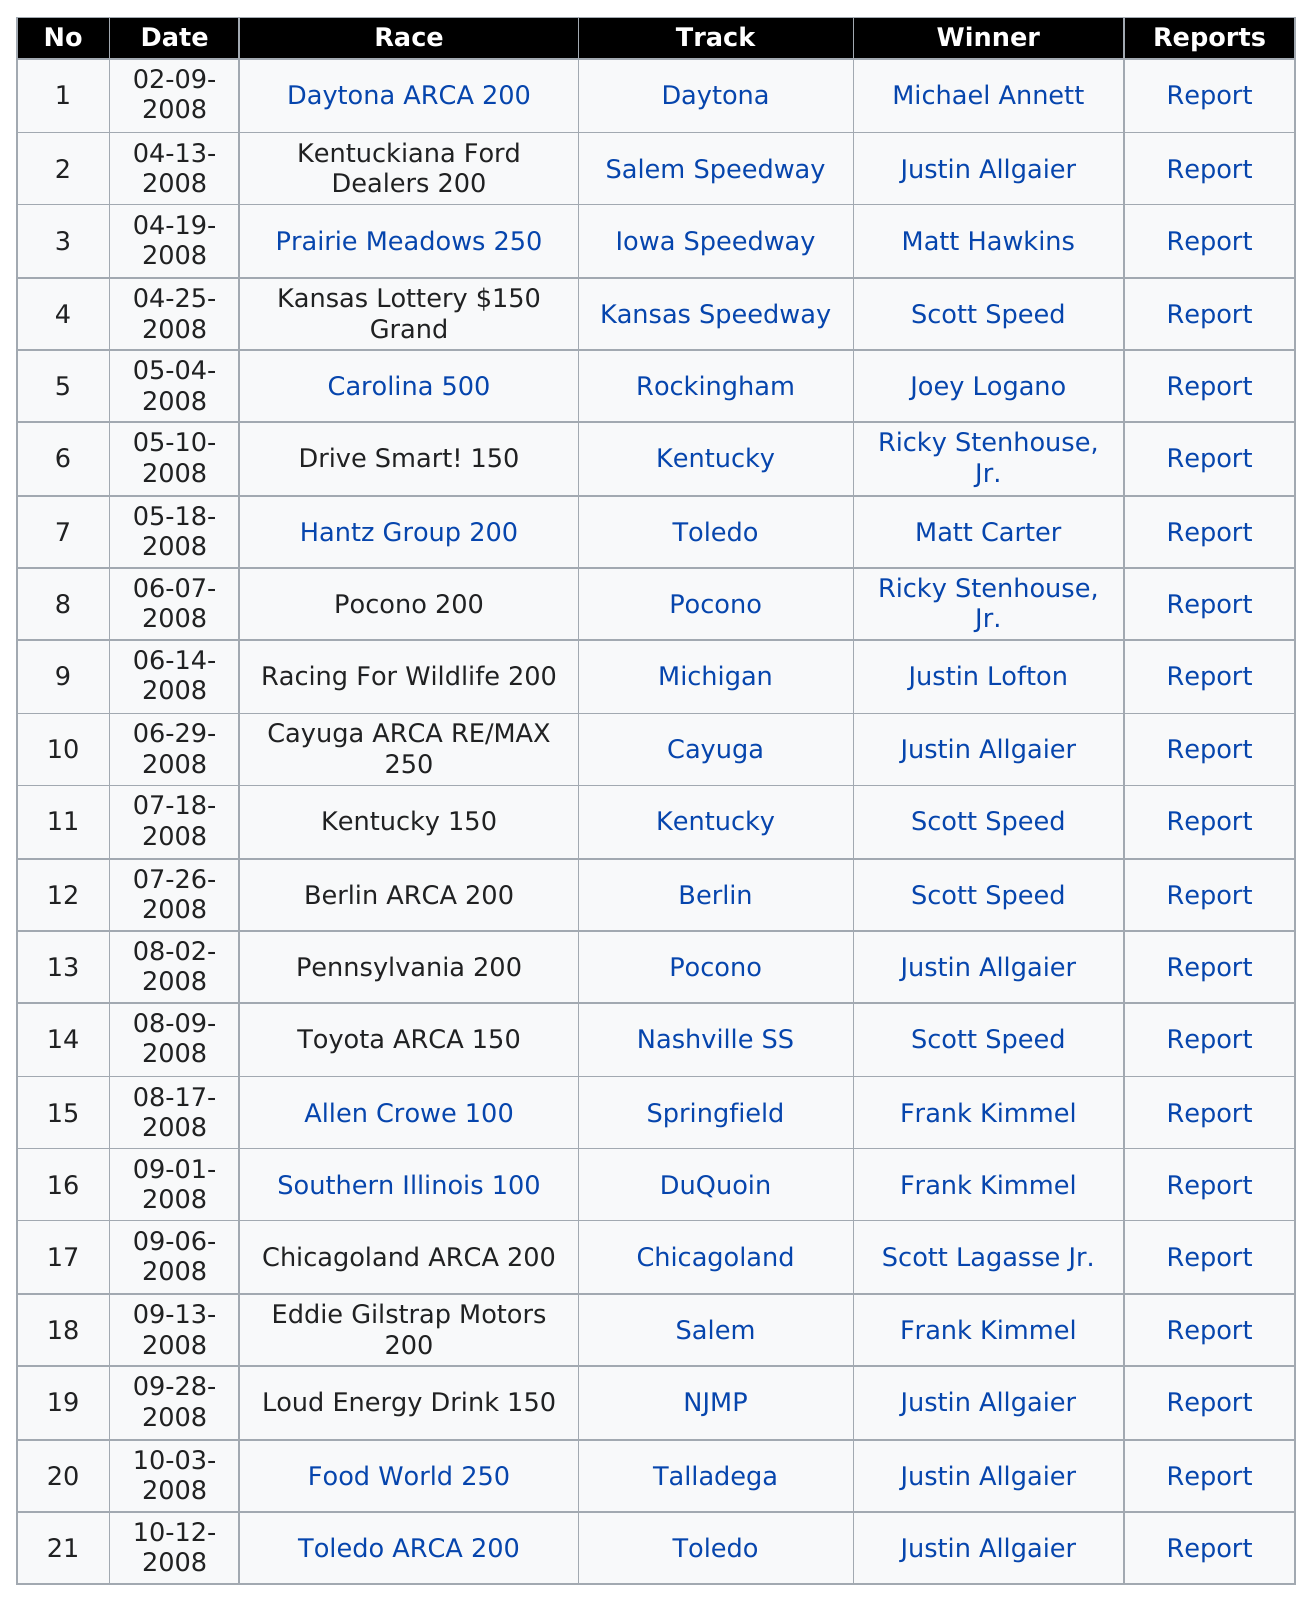Draw attention to some important aspects in this diagram. There are 100 races. Frank Kimmel last held a race in Salem. Ricky Stenhouse, Jr. participated in 2 races during this season. The competitor who was the top at the Carolina 500 is Joey Logano. The Racing For Wildlife 200 was held after the race that was held in Pocono. 